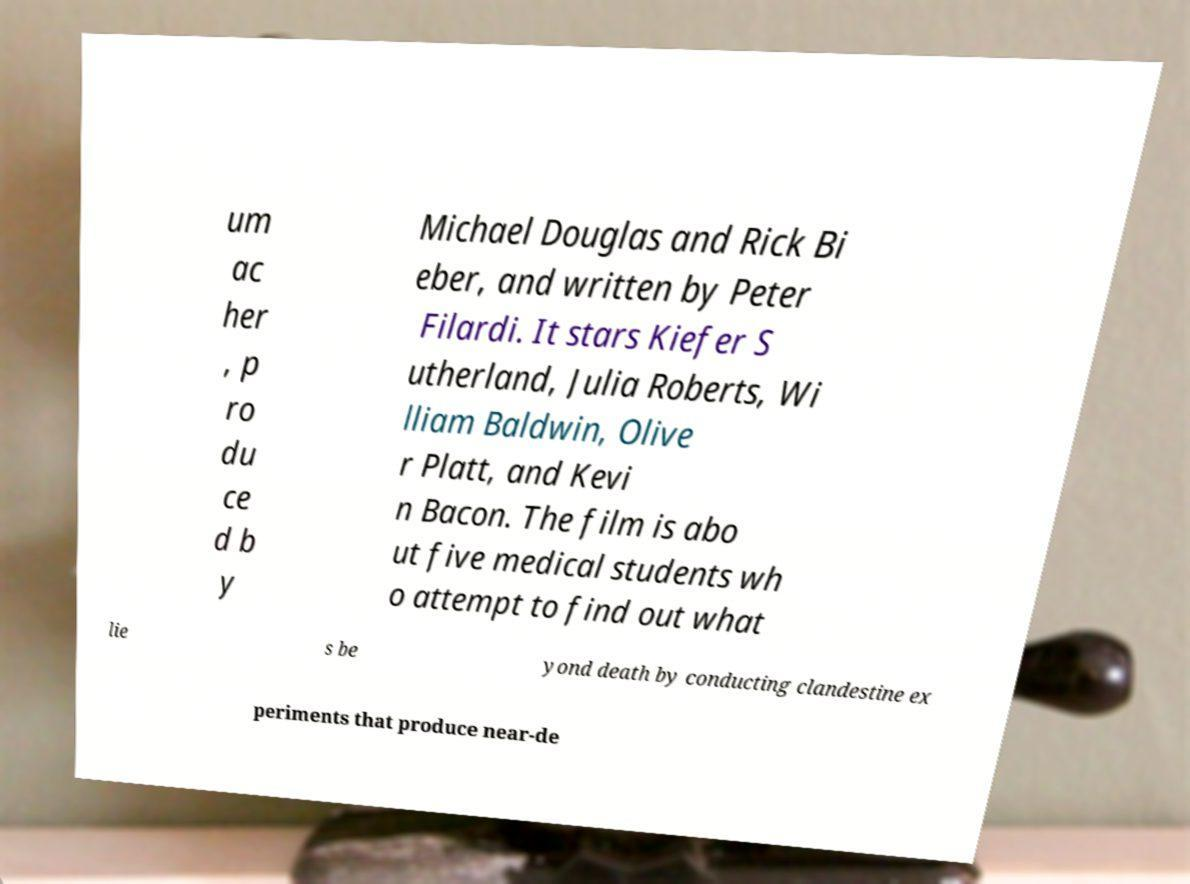Could you assist in decoding the text presented in this image and type it out clearly? um ac her , p ro du ce d b y Michael Douglas and Rick Bi eber, and written by Peter Filardi. It stars Kiefer S utherland, Julia Roberts, Wi lliam Baldwin, Olive r Platt, and Kevi n Bacon. The film is abo ut five medical students wh o attempt to find out what lie s be yond death by conducting clandestine ex periments that produce near-de 